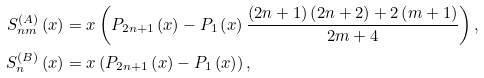Convert formula to latex. <formula><loc_0><loc_0><loc_500><loc_500>S _ { n m } ^ { ( A ) } \left ( x \right ) & = x \left ( P _ { 2 n + 1 } \left ( x \right ) - P _ { 1 } \left ( x \right ) \frac { \left ( 2 n + 1 \right ) \left ( 2 n + 2 \right ) + 2 \left ( m + 1 \right ) } { 2 m + 4 } \right ) , \\ S _ { n } ^ { ( B ) } \left ( x \right ) & = x \left ( P _ { 2 n + 1 } \left ( x \right ) - P _ { 1 } \left ( x \right ) \right ) ,</formula> 